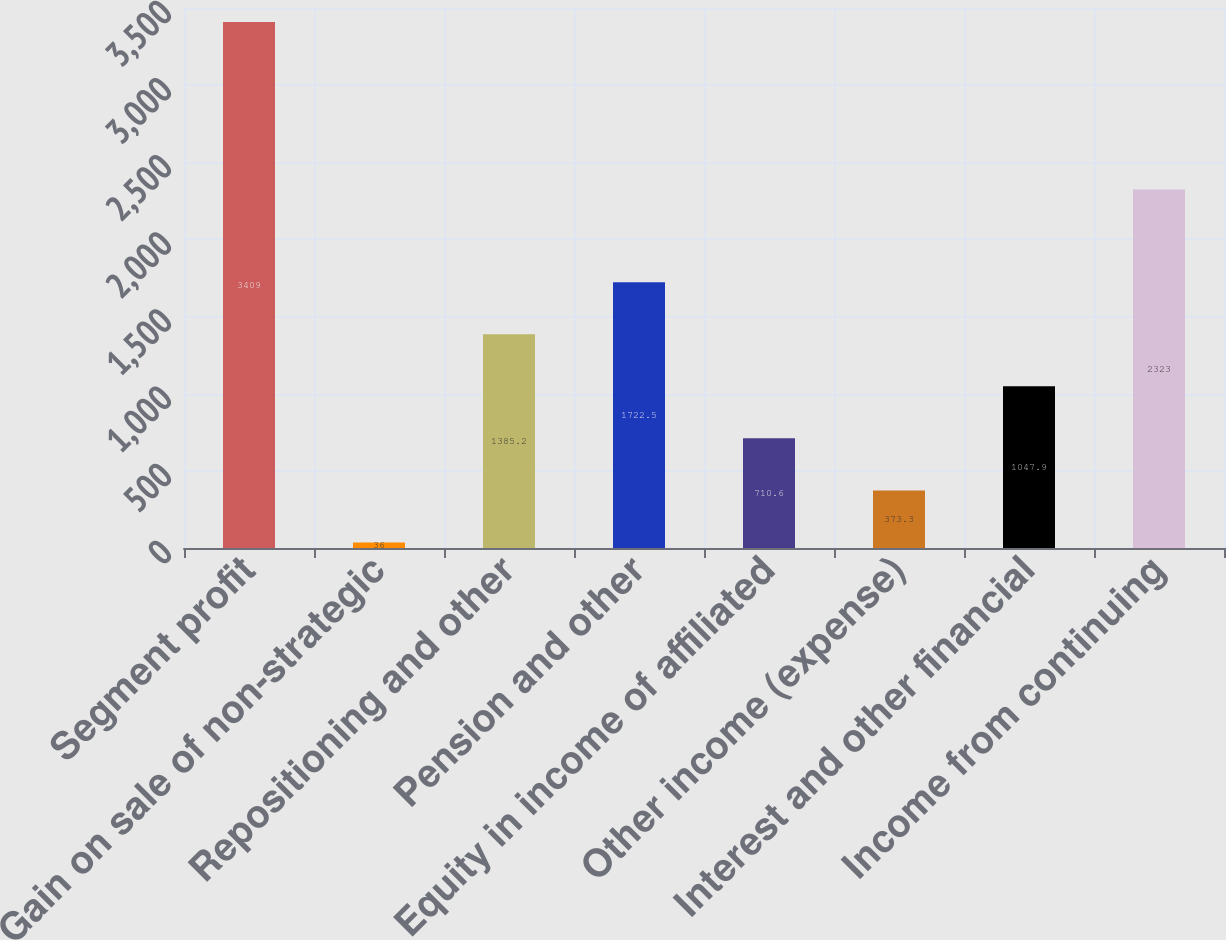Convert chart. <chart><loc_0><loc_0><loc_500><loc_500><bar_chart><fcel>Segment profit<fcel>Gain on sale of non-strategic<fcel>Repositioning and other<fcel>Pension and other<fcel>Equity in income of affiliated<fcel>Other income (expense)<fcel>Interest and other financial<fcel>Income from continuing<nl><fcel>3409<fcel>36<fcel>1385.2<fcel>1722.5<fcel>710.6<fcel>373.3<fcel>1047.9<fcel>2323<nl></chart> 